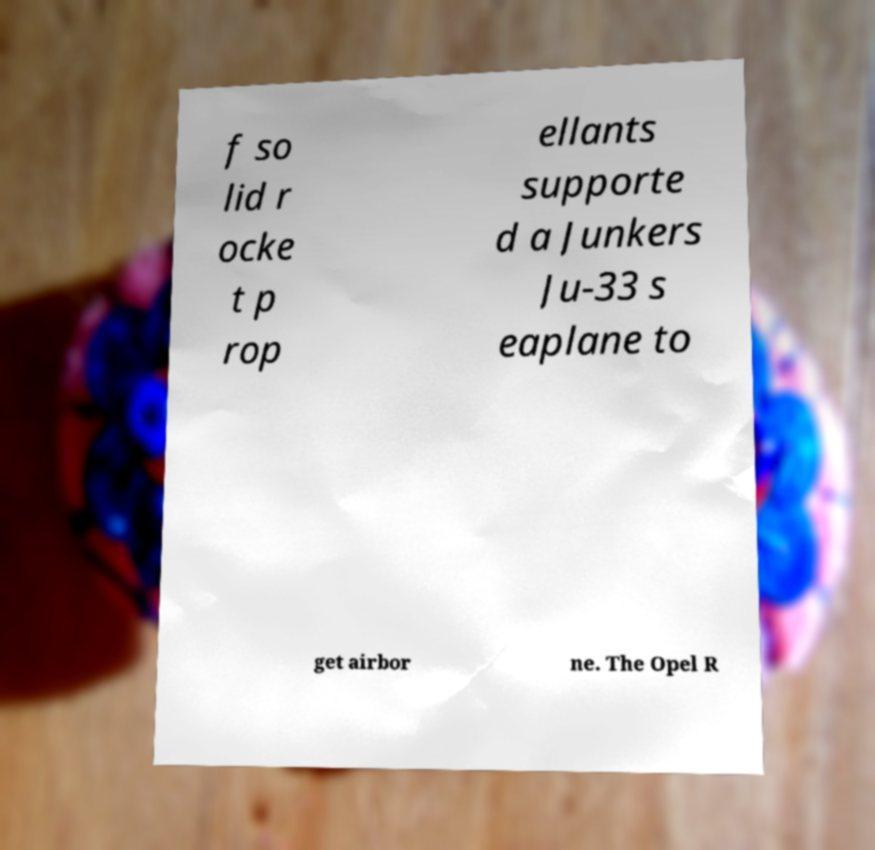I need the written content from this picture converted into text. Can you do that? f so lid r ocke t p rop ellants supporte d a Junkers Ju-33 s eaplane to get airbor ne. The Opel R 